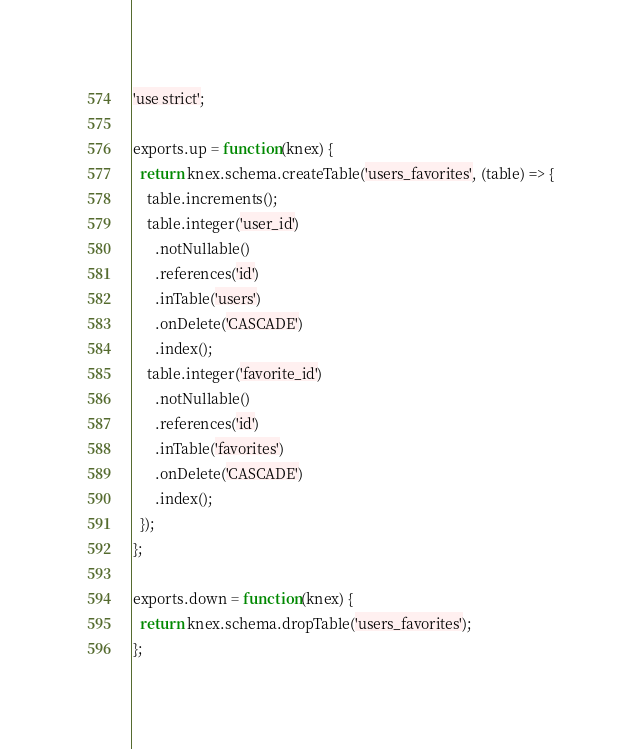Convert code to text. <code><loc_0><loc_0><loc_500><loc_500><_JavaScript_>'use strict';

exports.up = function(knex) {
  return knex.schema.createTable('users_favorites', (table) => {
    table.increments();
    table.integer('user_id')
      .notNullable()
      .references('id')
      .inTable('users')
      .onDelete('CASCADE')
      .index();
    table.integer('favorite_id')
      .notNullable()
      .references('id')
      .inTable('favorites')
      .onDelete('CASCADE')
      .index();
  });
};

exports.down = function(knex) {
  return knex.schema.dropTable('users_favorites');
};
</code> 